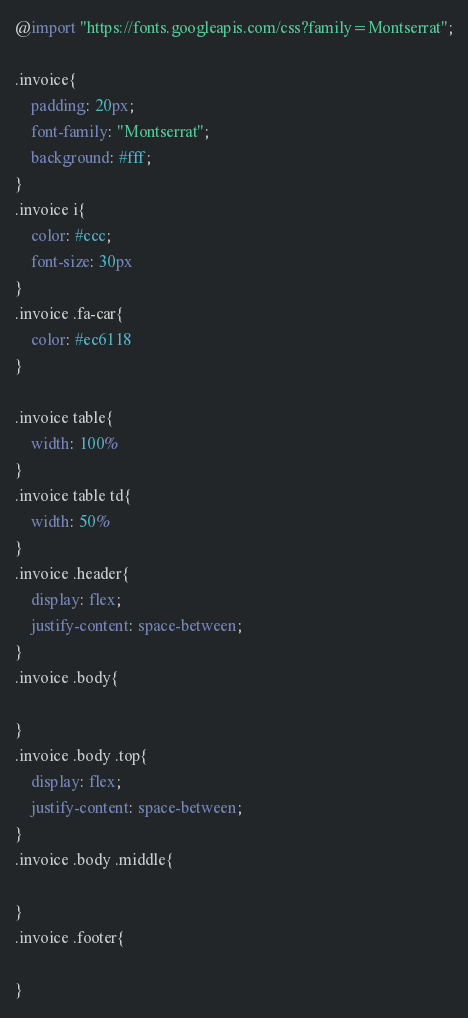<code> <loc_0><loc_0><loc_500><loc_500><_CSS_>@import "https://fonts.googleapis.com/css?family=Montserrat";

.invoice{
    padding: 20px;
    font-family: "Montserrat";
    background: #fff;
}
.invoice i{
    color: #ccc;
    font-size: 30px
}
.invoice .fa-car{
    color: #ec6118
}

.invoice table{
    width: 100%
}
.invoice table td{
    width: 50%
}
.invoice .header{
    display: flex;
    justify-content: space-between;
}
.invoice .body{

}
.invoice .body .top{
    display: flex;
    justify-content: space-between;
}
.invoice .body .middle{

}
.invoice .footer{

}</code> 